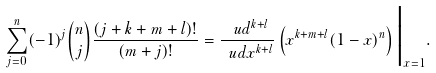Convert formula to latex. <formula><loc_0><loc_0><loc_500><loc_500>\sum _ { j = 0 } ^ { n } ( - 1 ) ^ { j } { n \choose j } \frac { ( j + k + m + l ) ! } { ( m + j ) ! } = \frac { \ u d ^ { k + l } } { \ u d x ^ { k + l } } \left ( x ^ { k + m + l } ( 1 - x ) ^ { n } \right ) \Big | _ { x = 1 } .</formula> 